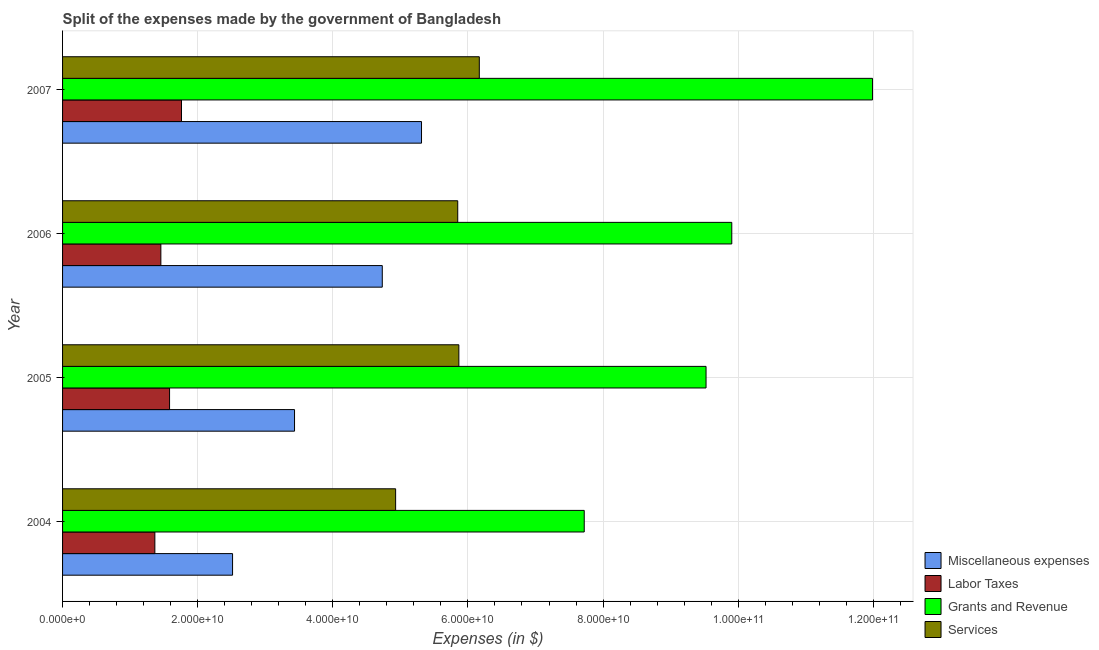Are the number of bars per tick equal to the number of legend labels?
Offer a terse response. Yes. How many bars are there on the 2nd tick from the top?
Provide a succinct answer. 4. In how many cases, is the number of bars for a given year not equal to the number of legend labels?
Give a very brief answer. 0. What is the amount spent on grants and revenue in 2007?
Provide a succinct answer. 1.20e+11. Across all years, what is the maximum amount spent on labor taxes?
Your response must be concise. 1.76e+1. Across all years, what is the minimum amount spent on grants and revenue?
Your answer should be compact. 7.72e+1. In which year was the amount spent on labor taxes minimum?
Make the answer very short. 2004. What is the total amount spent on labor taxes in the graph?
Give a very brief answer. 6.17e+1. What is the difference between the amount spent on labor taxes in 2005 and that in 2007?
Ensure brevity in your answer.  -1.77e+09. What is the difference between the amount spent on grants and revenue in 2006 and the amount spent on miscellaneous expenses in 2007?
Offer a very short reply. 4.59e+1. What is the average amount spent on grants and revenue per year?
Provide a short and direct response. 9.79e+1. In the year 2007, what is the difference between the amount spent on grants and revenue and amount spent on services?
Keep it short and to the point. 5.82e+1. Is the amount spent on services in 2005 less than that in 2006?
Keep it short and to the point. No. What is the difference between the highest and the second highest amount spent on grants and revenue?
Provide a succinct answer. 2.08e+1. What is the difference between the highest and the lowest amount spent on labor taxes?
Your answer should be compact. 3.94e+09. What does the 2nd bar from the top in 2005 represents?
Ensure brevity in your answer.  Grants and Revenue. What does the 2nd bar from the bottom in 2005 represents?
Provide a short and direct response. Labor Taxes. Is it the case that in every year, the sum of the amount spent on miscellaneous expenses and amount spent on labor taxes is greater than the amount spent on grants and revenue?
Your response must be concise. No. How many bars are there?
Keep it short and to the point. 16. Are all the bars in the graph horizontal?
Give a very brief answer. Yes. What is the difference between two consecutive major ticks on the X-axis?
Give a very brief answer. 2.00e+1. Does the graph contain any zero values?
Provide a succinct answer. No. Where does the legend appear in the graph?
Ensure brevity in your answer.  Bottom right. How many legend labels are there?
Your answer should be very brief. 4. What is the title of the graph?
Provide a short and direct response. Split of the expenses made by the government of Bangladesh. Does "Gender equality" appear as one of the legend labels in the graph?
Keep it short and to the point. No. What is the label or title of the X-axis?
Your response must be concise. Expenses (in $). What is the label or title of the Y-axis?
Make the answer very short. Year. What is the Expenses (in $) of Miscellaneous expenses in 2004?
Make the answer very short. 2.52e+1. What is the Expenses (in $) in Labor Taxes in 2004?
Your answer should be very brief. 1.37e+1. What is the Expenses (in $) of Grants and Revenue in 2004?
Your answer should be very brief. 7.72e+1. What is the Expenses (in $) of Services in 2004?
Your answer should be compact. 4.93e+1. What is the Expenses (in $) of Miscellaneous expenses in 2005?
Your answer should be very brief. 3.43e+1. What is the Expenses (in $) in Labor Taxes in 2005?
Provide a short and direct response. 1.58e+1. What is the Expenses (in $) in Grants and Revenue in 2005?
Give a very brief answer. 9.52e+1. What is the Expenses (in $) in Services in 2005?
Your answer should be very brief. 5.87e+1. What is the Expenses (in $) of Miscellaneous expenses in 2006?
Offer a terse response. 4.73e+1. What is the Expenses (in $) in Labor Taxes in 2006?
Provide a short and direct response. 1.45e+1. What is the Expenses (in $) in Grants and Revenue in 2006?
Provide a succinct answer. 9.91e+1. What is the Expenses (in $) of Services in 2006?
Provide a succinct answer. 5.85e+1. What is the Expenses (in $) of Miscellaneous expenses in 2007?
Ensure brevity in your answer.  5.31e+1. What is the Expenses (in $) of Labor Taxes in 2007?
Keep it short and to the point. 1.76e+1. What is the Expenses (in $) in Grants and Revenue in 2007?
Provide a succinct answer. 1.20e+11. What is the Expenses (in $) of Services in 2007?
Your answer should be very brief. 6.17e+1. Across all years, what is the maximum Expenses (in $) of Miscellaneous expenses?
Offer a very short reply. 5.31e+1. Across all years, what is the maximum Expenses (in $) of Labor Taxes?
Your response must be concise. 1.76e+1. Across all years, what is the maximum Expenses (in $) of Grants and Revenue?
Provide a short and direct response. 1.20e+11. Across all years, what is the maximum Expenses (in $) in Services?
Provide a short and direct response. 6.17e+1. Across all years, what is the minimum Expenses (in $) of Miscellaneous expenses?
Keep it short and to the point. 2.52e+1. Across all years, what is the minimum Expenses (in $) in Labor Taxes?
Provide a succinct answer. 1.37e+1. Across all years, what is the minimum Expenses (in $) of Grants and Revenue?
Provide a succinct answer. 7.72e+1. Across all years, what is the minimum Expenses (in $) of Services?
Your response must be concise. 4.93e+1. What is the total Expenses (in $) in Miscellaneous expenses in the graph?
Offer a terse response. 1.60e+11. What is the total Expenses (in $) of Labor Taxes in the graph?
Keep it short and to the point. 6.17e+1. What is the total Expenses (in $) in Grants and Revenue in the graph?
Offer a very short reply. 3.91e+11. What is the total Expenses (in $) of Services in the graph?
Provide a succinct answer. 2.28e+11. What is the difference between the Expenses (in $) in Miscellaneous expenses in 2004 and that in 2005?
Give a very brief answer. -9.17e+09. What is the difference between the Expenses (in $) in Labor Taxes in 2004 and that in 2005?
Give a very brief answer. -2.18e+09. What is the difference between the Expenses (in $) in Grants and Revenue in 2004 and that in 2005?
Your answer should be compact. -1.80e+1. What is the difference between the Expenses (in $) in Services in 2004 and that in 2005?
Your answer should be very brief. -9.36e+09. What is the difference between the Expenses (in $) of Miscellaneous expenses in 2004 and that in 2006?
Keep it short and to the point. -2.22e+1. What is the difference between the Expenses (in $) in Labor Taxes in 2004 and that in 2006?
Offer a terse response. -8.88e+08. What is the difference between the Expenses (in $) of Grants and Revenue in 2004 and that in 2006?
Your answer should be very brief. -2.18e+1. What is the difference between the Expenses (in $) of Services in 2004 and that in 2006?
Your answer should be very brief. -9.19e+09. What is the difference between the Expenses (in $) in Miscellaneous expenses in 2004 and that in 2007?
Offer a very short reply. -2.80e+1. What is the difference between the Expenses (in $) of Labor Taxes in 2004 and that in 2007?
Provide a short and direct response. -3.94e+09. What is the difference between the Expenses (in $) in Grants and Revenue in 2004 and that in 2007?
Your answer should be very brief. -4.27e+1. What is the difference between the Expenses (in $) in Services in 2004 and that in 2007?
Ensure brevity in your answer.  -1.24e+1. What is the difference between the Expenses (in $) of Miscellaneous expenses in 2005 and that in 2006?
Make the answer very short. -1.30e+1. What is the difference between the Expenses (in $) of Labor Taxes in 2005 and that in 2006?
Keep it short and to the point. 1.29e+09. What is the difference between the Expenses (in $) in Grants and Revenue in 2005 and that in 2006?
Ensure brevity in your answer.  -3.81e+09. What is the difference between the Expenses (in $) in Services in 2005 and that in 2006?
Give a very brief answer. 1.67e+08. What is the difference between the Expenses (in $) in Miscellaneous expenses in 2005 and that in 2007?
Provide a succinct answer. -1.88e+1. What is the difference between the Expenses (in $) in Labor Taxes in 2005 and that in 2007?
Give a very brief answer. -1.77e+09. What is the difference between the Expenses (in $) of Grants and Revenue in 2005 and that in 2007?
Provide a succinct answer. -2.46e+1. What is the difference between the Expenses (in $) in Services in 2005 and that in 2007?
Give a very brief answer. -3.03e+09. What is the difference between the Expenses (in $) in Miscellaneous expenses in 2006 and that in 2007?
Offer a terse response. -5.81e+09. What is the difference between the Expenses (in $) of Labor Taxes in 2006 and that in 2007?
Provide a short and direct response. -3.05e+09. What is the difference between the Expenses (in $) of Grants and Revenue in 2006 and that in 2007?
Your answer should be compact. -2.08e+1. What is the difference between the Expenses (in $) of Services in 2006 and that in 2007?
Offer a very short reply. -3.20e+09. What is the difference between the Expenses (in $) of Miscellaneous expenses in 2004 and the Expenses (in $) of Labor Taxes in 2005?
Make the answer very short. 9.33e+09. What is the difference between the Expenses (in $) of Miscellaneous expenses in 2004 and the Expenses (in $) of Grants and Revenue in 2005?
Your answer should be very brief. -7.01e+1. What is the difference between the Expenses (in $) of Miscellaneous expenses in 2004 and the Expenses (in $) of Services in 2005?
Make the answer very short. -3.35e+1. What is the difference between the Expenses (in $) of Labor Taxes in 2004 and the Expenses (in $) of Grants and Revenue in 2005?
Your response must be concise. -8.16e+1. What is the difference between the Expenses (in $) of Labor Taxes in 2004 and the Expenses (in $) of Services in 2005?
Offer a terse response. -4.50e+1. What is the difference between the Expenses (in $) in Grants and Revenue in 2004 and the Expenses (in $) in Services in 2005?
Offer a very short reply. 1.86e+1. What is the difference between the Expenses (in $) of Miscellaneous expenses in 2004 and the Expenses (in $) of Labor Taxes in 2006?
Your response must be concise. 1.06e+1. What is the difference between the Expenses (in $) in Miscellaneous expenses in 2004 and the Expenses (in $) in Grants and Revenue in 2006?
Offer a terse response. -7.39e+1. What is the difference between the Expenses (in $) of Miscellaneous expenses in 2004 and the Expenses (in $) of Services in 2006?
Your response must be concise. -3.33e+1. What is the difference between the Expenses (in $) of Labor Taxes in 2004 and the Expenses (in $) of Grants and Revenue in 2006?
Offer a terse response. -8.54e+1. What is the difference between the Expenses (in $) of Labor Taxes in 2004 and the Expenses (in $) of Services in 2006?
Keep it short and to the point. -4.48e+1. What is the difference between the Expenses (in $) in Grants and Revenue in 2004 and the Expenses (in $) in Services in 2006?
Give a very brief answer. 1.87e+1. What is the difference between the Expenses (in $) in Miscellaneous expenses in 2004 and the Expenses (in $) in Labor Taxes in 2007?
Your response must be concise. 7.56e+09. What is the difference between the Expenses (in $) in Miscellaneous expenses in 2004 and the Expenses (in $) in Grants and Revenue in 2007?
Provide a short and direct response. -9.47e+1. What is the difference between the Expenses (in $) of Miscellaneous expenses in 2004 and the Expenses (in $) of Services in 2007?
Ensure brevity in your answer.  -3.65e+1. What is the difference between the Expenses (in $) of Labor Taxes in 2004 and the Expenses (in $) of Grants and Revenue in 2007?
Ensure brevity in your answer.  -1.06e+11. What is the difference between the Expenses (in $) in Labor Taxes in 2004 and the Expenses (in $) in Services in 2007?
Make the answer very short. -4.80e+1. What is the difference between the Expenses (in $) in Grants and Revenue in 2004 and the Expenses (in $) in Services in 2007?
Make the answer very short. 1.55e+1. What is the difference between the Expenses (in $) of Miscellaneous expenses in 2005 and the Expenses (in $) of Labor Taxes in 2006?
Your response must be concise. 1.98e+1. What is the difference between the Expenses (in $) in Miscellaneous expenses in 2005 and the Expenses (in $) in Grants and Revenue in 2006?
Make the answer very short. -6.47e+1. What is the difference between the Expenses (in $) in Miscellaneous expenses in 2005 and the Expenses (in $) in Services in 2006?
Your answer should be compact. -2.42e+1. What is the difference between the Expenses (in $) in Labor Taxes in 2005 and the Expenses (in $) in Grants and Revenue in 2006?
Make the answer very short. -8.32e+1. What is the difference between the Expenses (in $) of Labor Taxes in 2005 and the Expenses (in $) of Services in 2006?
Offer a very short reply. -4.27e+1. What is the difference between the Expenses (in $) in Grants and Revenue in 2005 and the Expenses (in $) in Services in 2006?
Provide a short and direct response. 3.68e+1. What is the difference between the Expenses (in $) in Miscellaneous expenses in 2005 and the Expenses (in $) in Labor Taxes in 2007?
Ensure brevity in your answer.  1.67e+1. What is the difference between the Expenses (in $) of Miscellaneous expenses in 2005 and the Expenses (in $) of Grants and Revenue in 2007?
Your answer should be very brief. -8.56e+1. What is the difference between the Expenses (in $) in Miscellaneous expenses in 2005 and the Expenses (in $) in Services in 2007?
Provide a short and direct response. -2.74e+1. What is the difference between the Expenses (in $) in Labor Taxes in 2005 and the Expenses (in $) in Grants and Revenue in 2007?
Offer a very short reply. -1.04e+11. What is the difference between the Expenses (in $) in Labor Taxes in 2005 and the Expenses (in $) in Services in 2007?
Your response must be concise. -4.58e+1. What is the difference between the Expenses (in $) in Grants and Revenue in 2005 and the Expenses (in $) in Services in 2007?
Give a very brief answer. 3.36e+1. What is the difference between the Expenses (in $) of Miscellaneous expenses in 2006 and the Expenses (in $) of Labor Taxes in 2007?
Provide a succinct answer. 2.97e+1. What is the difference between the Expenses (in $) in Miscellaneous expenses in 2006 and the Expenses (in $) in Grants and Revenue in 2007?
Offer a terse response. -7.26e+1. What is the difference between the Expenses (in $) in Miscellaneous expenses in 2006 and the Expenses (in $) in Services in 2007?
Your response must be concise. -1.44e+1. What is the difference between the Expenses (in $) in Labor Taxes in 2006 and the Expenses (in $) in Grants and Revenue in 2007?
Ensure brevity in your answer.  -1.05e+11. What is the difference between the Expenses (in $) in Labor Taxes in 2006 and the Expenses (in $) in Services in 2007?
Your answer should be very brief. -4.71e+1. What is the difference between the Expenses (in $) in Grants and Revenue in 2006 and the Expenses (in $) in Services in 2007?
Make the answer very short. 3.74e+1. What is the average Expenses (in $) in Miscellaneous expenses per year?
Offer a terse response. 4.00e+1. What is the average Expenses (in $) of Labor Taxes per year?
Ensure brevity in your answer.  1.54e+1. What is the average Expenses (in $) of Grants and Revenue per year?
Make the answer very short. 9.79e+1. What is the average Expenses (in $) of Services per year?
Your answer should be compact. 5.70e+1. In the year 2004, what is the difference between the Expenses (in $) in Miscellaneous expenses and Expenses (in $) in Labor Taxes?
Ensure brevity in your answer.  1.15e+1. In the year 2004, what is the difference between the Expenses (in $) of Miscellaneous expenses and Expenses (in $) of Grants and Revenue?
Provide a short and direct response. -5.21e+1. In the year 2004, what is the difference between the Expenses (in $) in Miscellaneous expenses and Expenses (in $) in Services?
Your response must be concise. -2.41e+1. In the year 2004, what is the difference between the Expenses (in $) in Labor Taxes and Expenses (in $) in Grants and Revenue?
Give a very brief answer. -6.36e+1. In the year 2004, what is the difference between the Expenses (in $) of Labor Taxes and Expenses (in $) of Services?
Offer a very short reply. -3.56e+1. In the year 2004, what is the difference between the Expenses (in $) of Grants and Revenue and Expenses (in $) of Services?
Keep it short and to the point. 2.79e+1. In the year 2005, what is the difference between the Expenses (in $) in Miscellaneous expenses and Expenses (in $) in Labor Taxes?
Your response must be concise. 1.85e+1. In the year 2005, what is the difference between the Expenses (in $) in Miscellaneous expenses and Expenses (in $) in Grants and Revenue?
Your answer should be very brief. -6.09e+1. In the year 2005, what is the difference between the Expenses (in $) in Miscellaneous expenses and Expenses (in $) in Services?
Your answer should be compact. -2.43e+1. In the year 2005, what is the difference between the Expenses (in $) in Labor Taxes and Expenses (in $) in Grants and Revenue?
Keep it short and to the point. -7.94e+1. In the year 2005, what is the difference between the Expenses (in $) of Labor Taxes and Expenses (in $) of Services?
Provide a short and direct response. -4.28e+1. In the year 2005, what is the difference between the Expenses (in $) in Grants and Revenue and Expenses (in $) in Services?
Provide a succinct answer. 3.66e+1. In the year 2006, what is the difference between the Expenses (in $) of Miscellaneous expenses and Expenses (in $) of Labor Taxes?
Your answer should be compact. 3.28e+1. In the year 2006, what is the difference between the Expenses (in $) in Miscellaneous expenses and Expenses (in $) in Grants and Revenue?
Your answer should be compact. -5.17e+1. In the year 2006, what is the difference between the Expenses (in $) in Miscellaneous expenses and Expenses (in $) in Services?
Make the answer very short. -1.12e+1. In the year 2006, what is the difference between the Expenses (in $) in Labor Taxes and Expenses (in $) in Grants and Revenue?
Offer a very short reply. -8.45e+1. In the year 2006, what is the difference between the Expenses (in $) of Labor Taxes and Expenses (in $) of Services?
Your answer should be compact. -4.39e+1. In the year 2006, what is the difference between the Expenses (in $) of Grants and Revenue and Expenses (in $) of Services?
Provide a short and direct response. 4.06e+1. In the year 2007, what is the difference between the Expenses (in $) of Miscellaneous expenses and Expenses (in $) of Labor Taxes?
Provide a succinct answer. 3.55e+1. In the year 2007, what is the difference between the Expenses (in $) of Miscellaneous expenses and Expenses (in $) of Grants and Revenue?
Make the answer very short. -6.68e+1. In the year 2007, what is the difference between the Expenses (in $) in Miscellaneous expenses and Expenses (in $) in Services?
Provide a short and direct response. -8.55e+09. In the year 2007, what is the difference between the Expenses (in $) in Labor Taxes and Expenses (in $) in Grants and Revenue?
Your answer should be compact. -1.02e+11. In the year 2007, what is the difference between the Expenses (in $) of Labor Taxes and Expenses (in $) of Services?
Give a very brief answer. -4.41e+1. In the year 2007, what is the difference between the Expenses (in $) in Grants and Revenue and Expenses (in $) in Services?
Your response must be concise. 5.82e+1. What is the ratio of the Expenses (in $) in Miscellaneous expenses in 2004 to that in 2005?
Make the answer very short. 0.73. What is the ratio of the Expenses (in $) in Labor Taxes in 2004 to that in 2005?
Offer a terse response. 0.86. What is the ratio of the Expenses (in $) of Grants and Revenue in 2004 to that in 2005?
Provide a succinct answer. 0.81. What is the ratio of the Expenses (in $) in Services in 2004 to that in 2005?
Provide a short and direct response. 0.84. What is the ratio of the Expenses (in $) of Miscellaneous expenses in 2004 to that in 2006?
Offer a very short reply. 0.53. What is the ratio of the Expenses (in $) in Labor Taxes in 2004 to that in 2006?
Make the answer very short. 0.94. What is the ratio of the Expenses (in $) in Grants and Revenue in 2004 to that in 2006?
Your answer should be compact. 0.78. What is the ratio of the Expenses (in $) of Services in 2004 to that in 2006?
Your answer should be very brief. 0.84. What is the ratio of the Expenses (in $) of Miscellaneous expenses in 2004 to that in 2007?
Provide a succinct answer. 0.47. What is the ratio of the Expenses (in $) of Labor Taxes in 2004 to that in 2007?
Offer a terse response. 0.78. What is the ratio of the Expenses (in $) of Grants and Revenue in 2004 to that in 2007?
Your answer should be compact. 0.64. What is the ratio of the Expenses (in $) in Services in 2004 to that in 2007?
Give a very brief answer. 0.8. What is the ratio of the Expenses (in $) of Miscellaneous expenses in 2005 to that in 2006?
Your response must be concise. 0.73. What is the ratio of the Expenses (in $) of Labor Taxes in 2005 to that in 2006?
Give a very brief answer. 1.09. What is the ratio of the Expenses (in $) in Grants and Revenue in 2005 to that in 2006?
Provide a succinct answer. 0.96. What is the ratio of the Expenses (in $) in Services in 2005 to that in 2006?
Your answer should be compact. 1. What is the ratio of the Expenses (in $) of Miscellaneous expenses in 2005 to that in 2007?
Keep it short and to the point. 0.65. What is the ratio of the Expenses (in $) in Labor Taxes in 2005 to that in 2007?
Make the answer very short. 0.9. What is the ratio of the Expenses (in $) in Grants and Revenue in 2005 to that in 2007?
Give a very brief answer. 0.79. What is the ratio of the Expenses (in $) of Services in 2005 to that in 2007?
Offer a very short reply. 0.95. What is the ratio of the Expenses (in $) in Miscellaneous expenses in 2006 to that in 2007?
Your answer should be very brief. 0.89. What is the ratio of the Expenses (in $) of Labor Taxes in 2006 to that in 2007?
Offer a terse response. 0.83. What is the ratio of the Expenses (in $) in Grants and Revenue in 2006 to that in 2007?
Your response must be concise. 0.83. What is the ratio of the Expenses (in $) in Services in 2006 to that in 2007?
Provide a short and direct response. 0.95. What is the difference between the highest and the second highest Expenses (in $) in Miscellaneous expenses?
Provide a short and direct response. 5.81e+09. What is the difference between the highest and the second highest Expenses (in $) of Labor Taxes?
Make the answer very short. 1.77e+09. What is the difference between the highest and the second highest Expenses (in $) of Grants and Revenue?
Your answer should be very brief. 2.08e+1. What is the difference between the highest and the second highest Expenses (in $) of Services?
Give a very brief answer. 3.03e+09. What is the difference between the highest and the lowest Expenses (in $) of Miscellaneous expenses?
Your response must be concise. 2.80e+1. What is the difference between the highest and the lowest Expenses (in $) of Labor Taxes?
Provide a succinct answer. 3.94e+09. What is the difference between the highest and the lowest Expenses (in $) in Grants and Revenue?
Make the answer very short. 4.27e+1. What is the difference between the highest and the lowest Expenses (in $) of Services?
Offer a very short reply. 1.24e+1. 